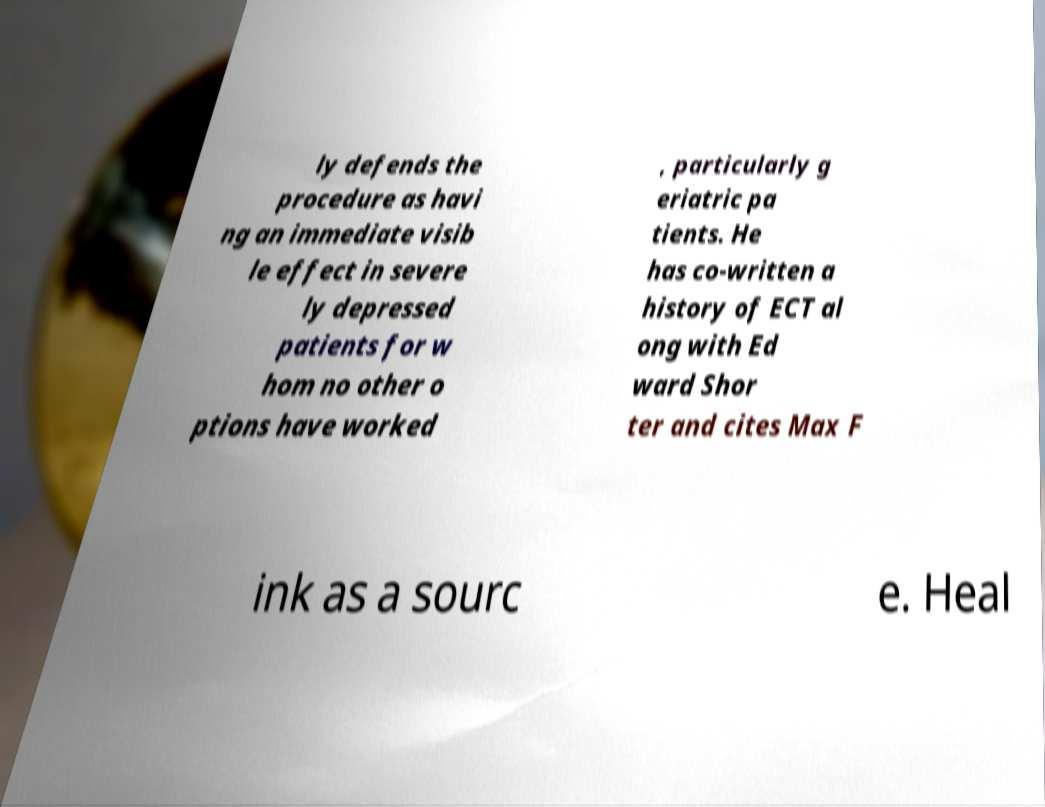Please identify and transcribe the text found in this image. ly defends the procedure as havi ng an immediate visib le effect in severe ly depressed patients for w hom no other o ptions have worked , particularly g eriatric pa tients. He has co-written a history of ECT al ong with Ed ward Shor ter and cites Max F ink as a sourc e. Heal 